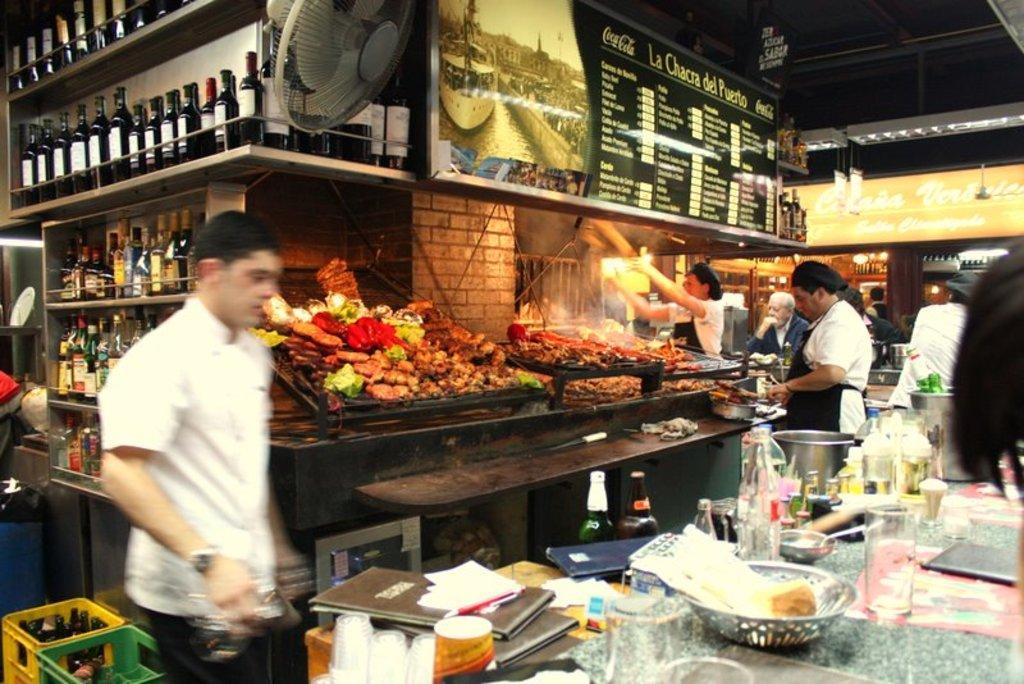Can you describe this image briefly? In this race there are bottles. Here we can see board, fan and food. Beside this table there are people. On this table there are glasses, bottles and things. 